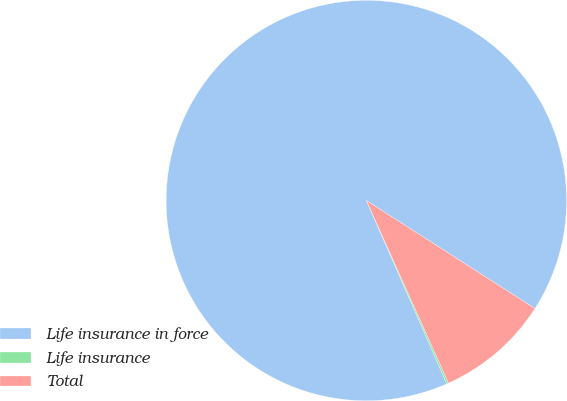<chart> <loc_0><loc_0><loc_500><loc_500><pie_chart><fcel>Life insurance in force<fcel>Life insurance<fcel>Total<nl><fcel>90.64%<fcel>0.15%<fcel>9.2%<nl></chart> 